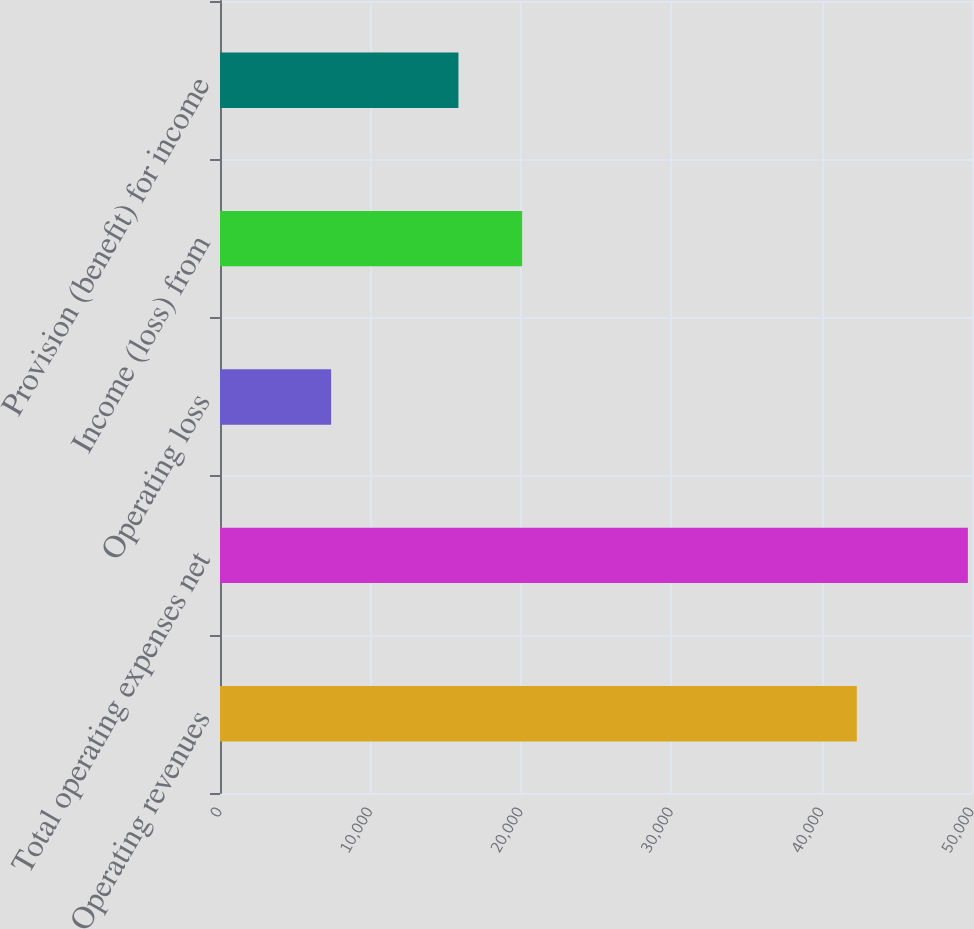Convert chart. <chart><loc_0><loc_0><loc_500><loc_500><bar_chart><fcel>Operating revenues<fcel>Total operating expenses net<fcel>Operating loss<fcel>Income (loss) from<fcel>Provision (benefit) for income<nl><fcel>42341<fcel>49726<fcel>7385<fcel>20087.3<fcel>15853.2<nl></chart> 